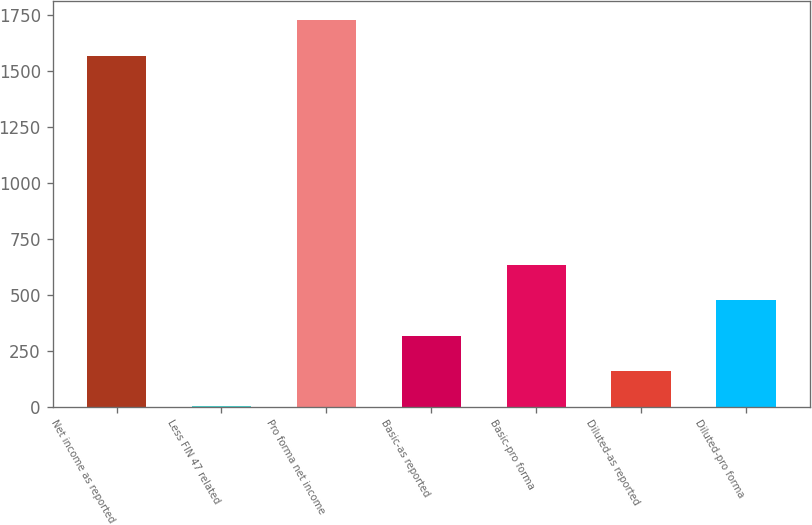Convert chart to OTSL. <chart><loc_0><loc_0><loc_500><loc_500><bar_chart><fcel>Net income as reported<fcel>Less FIN 47 related<fcel>Pro forma net income<fcel>Basic-as reported<fcel>Basic-pro forma<fcel>Diluted-as reported<fcel>Diluted-pro forma<nl><fcel>1568.3<fcel>1.2<fcel>1726.12<fcel>316.84<fcel>632.48<fcel>159.02<fcel>474.66<nl></chart> 